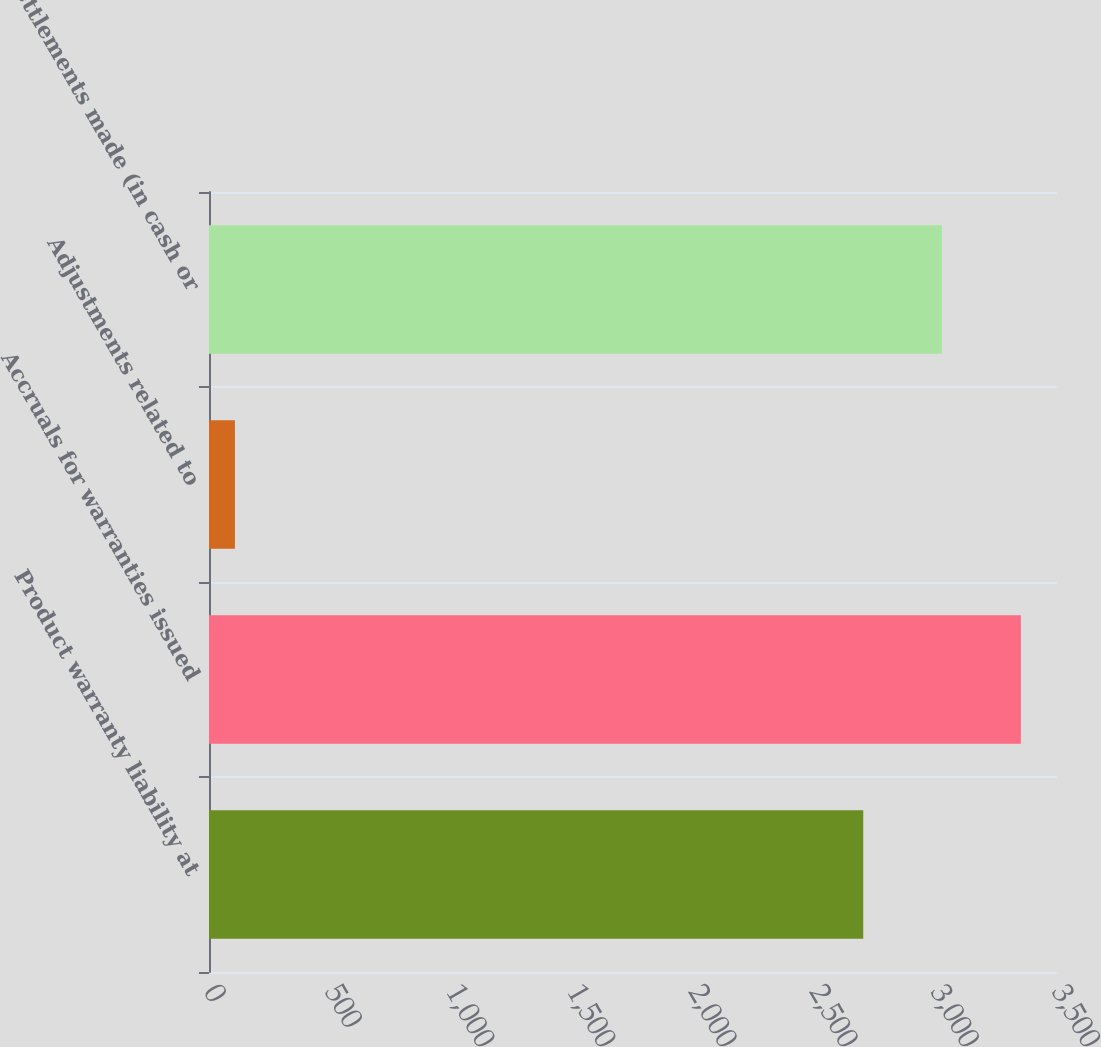<chart> <loc_0><loc_0><loc_500><loc_500><bar_chart><fcel>Product warranty liability at<fcel>Accruals for warranties issued<fcel>Adjustments related to<fcel>Settlements made (in cash or<nl><fcel>2700.4<fcel>3351<fcel>107<fcel>3024.8<nl></chart> 